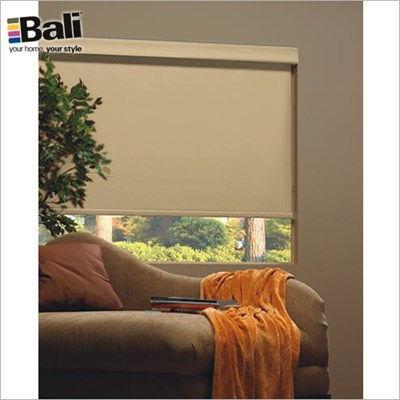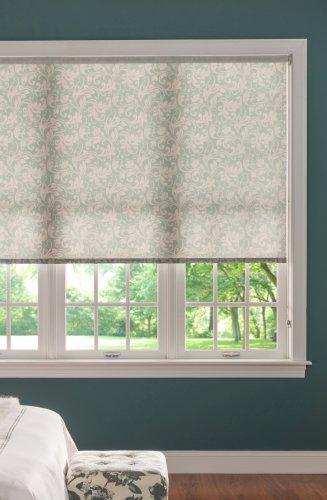The first image is the image on the left, the second image is the image on the right. Considering the images on both sides, is "The left and right image contains the same number of blinds." valid? Answer yes or no. Yes. The first image is the image on the left, the second image is the image on the right. Evaluate the accuracy of this statement regarding the images: "At least one of the images is focused on a single window, with a black shade drawn most of the way down.". Is it true? Answer yes or no. No. 